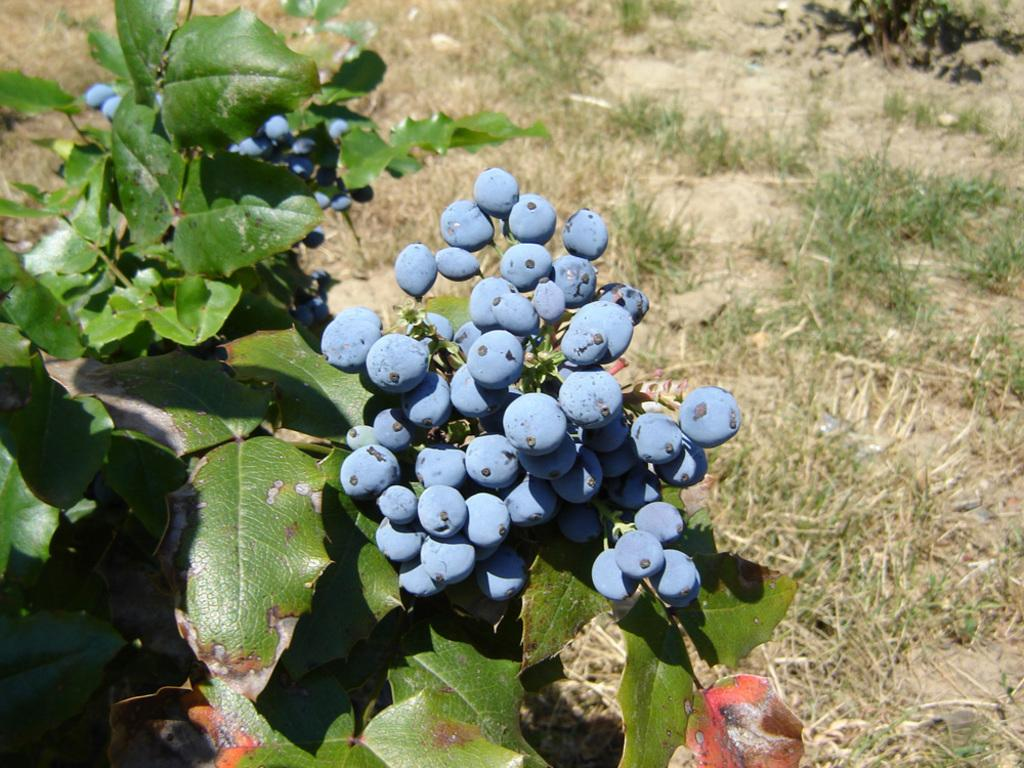What type of living organisms can be seen in the image? Plants can be seen in the image. What is unique about the berries on the plants? The berries on the plants have a blue color. What type of vegetation is visible in the background of the image? Grass is visible in the background of the image. How many sticks are leaning against the hydrant in the image? There is no hydrant or sticks present in the image. What point is the image trying to make about the environment? The image does not make a specific point about the environment; it simply shows plants with blue berries and grass in the background. 